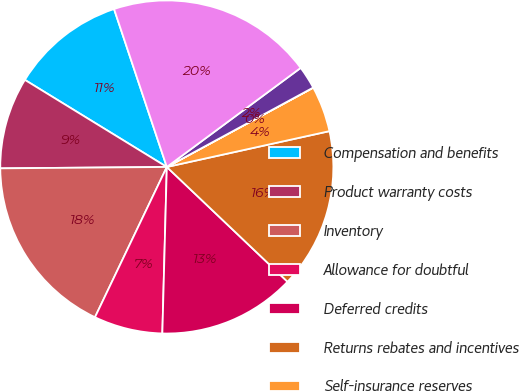Convert chart. <chart><loc_0><loc_0><loc_500><loc_500><pie_chart><fcel>Compensation and benefits<fcel>Product warranty costs<fcel>Inventory<fcel>Allowance for doubtful<fcel>Deferred credits<fcel>Returns rebates and incentives<fcel>Self-insurance reserves<fcel>Net operating loss<fcel>State tax credit carryforwards<fcel>Other - net<nl><fcel>11.11%<fcel>8.89%<fcel>17.77%<fcel>6.67%<fcel>13.33%<fcel>15.55%<fcel>4.45%<fcel>0.01%<fcel>2.23%<fcel>19.99%<nl></chart> 